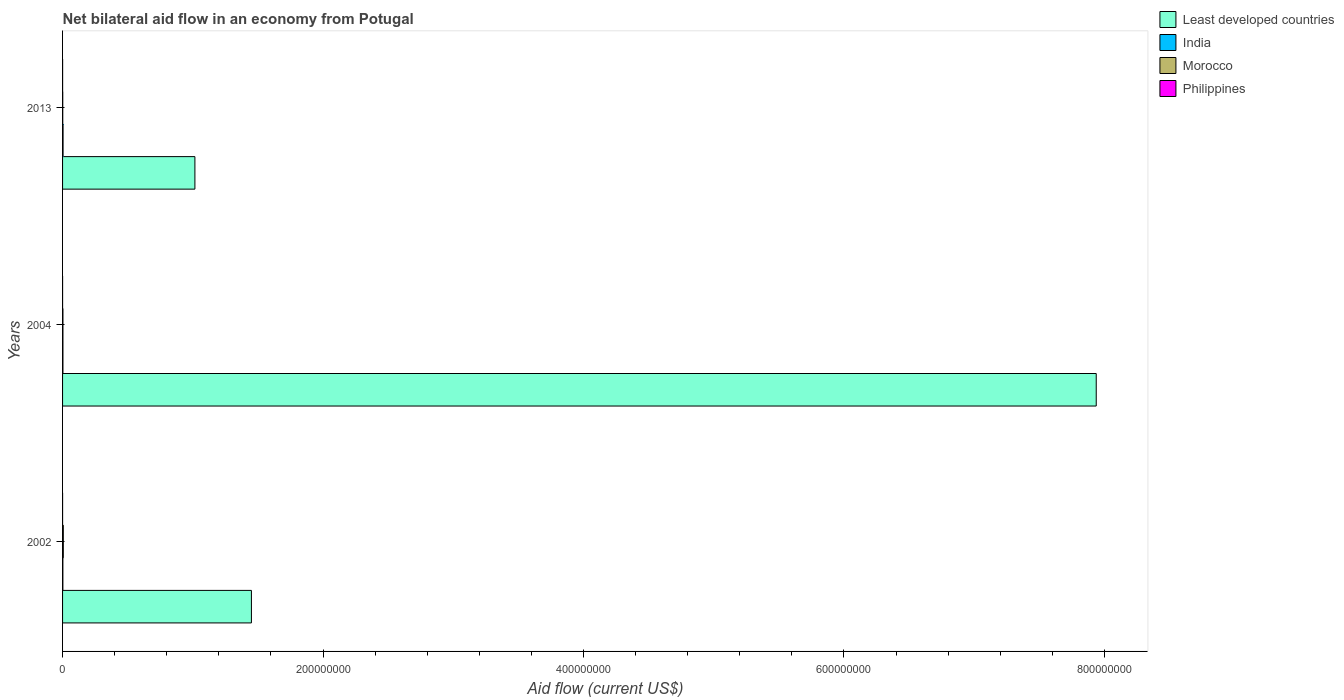How many different coloured bars are there?
Offer a terse response. 4. Are the number of bars per tick equal to the number of legend labels?
Make the answer very short. Yes. Are the number of bars on each tick of the Y-axis equal?
Provide a short and direct response. Yes. How many bars are there on the 3rd tick from the top?
Your answer should be compact. 4. Across all years, what is the maximum net bilateral aid flow in Morocco?
Your response must be concise. 5.70e+05. Across all years, what is the minimum net bilateral aid flow in Least developed countries?
Ensure brevity in your answer.  1.02e+08. In which year was the net bilateral aid flow in Morocco maximum?
Keep it short and to the point. 2002. What is the total net bilateral aid flow in Least developed countries in the graph?
Offer a very short reply. 1.04e+09. What is the difference between the net bilateral aid flow in Least developed countries in 2004 and that in 2013?
Provide a short and direct response. 6.92e+08. What is the difference between the net bilateral aid flow in India in 2004 and the net bilateral aid flow in Least developed countries in 2002?
Offer a very short reply. -1.45e+08. What is the average net bilateral aid flow in Morocco per year?
Your answer should be very brief. 3.33e+05. In the year 2002, what is the difference between the net bilateral aid flow in Least developed countries and net bilateral aid flow in Philippines?
Give a very brief answer. 1.45e+08. What is the ratio of the net bilateral aid flow in Least developed countries in 2002 to that in 2013?
Keep it short and to the point. 1.43. In how many years, is the net bilateral aid flow in Least developed countries greater than the average net bilateral aid flow in Least developed countries taken over all years?
Make the answer very short. 1. What does the 3rd bar from the top in 2004 represents?
Offer a very short reply. India. What does the 1st bar from the bottom in 2004 represents?
Ensure brevity in your answer.  Least developed countries. Is it the case that in every year, the sum of the net bilateral aid flow in India and net bilateral aid flow in Philippines is greater than the net bilateral aid flow in Least developed countries?
Provide a short and direct response. No. How many bars are there?
Offer a terse response. 12. Are all the bars in the graph horizontal?
Give a very brief answer. Yes. How many years are there in the graph?
Your response must be concise. 3. Does the graph contain any zero values?
Your answer should be compact. No. Does the graph contain grids?
Provide a short and direct response. No. What is the title of the graph?
Provide a succinct answer. Net bilateral aid flow in an economy from Potugal. What is the Aid flow (current US$) of Least developed countries in 2002?
Make the answer very short. 1.45e+08. What is the Aid flow (current US$) in Morocco in 2002?
Your answer should be compact. 5.70e+05. What is the Aid flow (current US$) of Least developed countries in 2004?
Your answer should be very brief. 7.94e+08. What is the Aid flow (current US$) in India in 2004?
Provide a short and direct response. 2.90e+05. What is the Aid flow (current US$) of Least developed countries in 2013?
Provide a succinct answer. 1.02e+08. What is the Aid flow (current US$) in Philippines in 2013?
Provide a short and direct response. 3.00e+04. Across all years, what is the maximum Aid flow (current US$) of Least developed countries?
Offer a terse response. 7.94e+08. Across all years, what is the maximum Aid flow (current US$) in India?
Offer a very short reply. 3.80e+05. Across all years, what is the maximum Aid flow (current US$) of Morocco?
Make the answer very short. 5.70e+05. Across all years, what is the minimum Aid flow (current US$) of Least developed countries?
Provide a short and direct response. 1.02e+08. Across all years, what is the minimum Aid flow (current US$) in Morocco?
Ensure brevity in your answer.  1.40e+05. What is the total Aid flow (current US$) of Least developed countries in the graph?
Make the answer very short. 1.04e+09. What is the total Aid flow (current US$) of India in the graph?
Give a very brief answer. 9.10e+05. What is the total Aid flow (current US$) of Morocco in the graph?
Keep it short and to the point. 1.00e+06. What is the total Aid flow (current US$) of Philippines in the graph?
Your answer should be compact. 5.00e+04. What is the difference between the Aid flow (current US$) in Least developed countries in 2002 and that in 2004?
Offer a very short reply. -6.49e+08. What is the difference between the Aid flow (current US$) of India in 2002 and that in 2004?
Provide a succinct answer. -5.00e+04. What is the difference between the Aid flow (current US$) of Philippines in 2002 and that in 2004?
Make the answer very short. 0. What is the difference between the Aid flow (current US$) of Least developed countries in 2002 and that in 2013?
Your response must be concise. 4.34e+07. What is the difference between the Aid flow (current US$) of Morocco in 2002 and that in 2013?
Your answer should be very brief. 4.30e+05. What is the difference between the Aid flow (current US$) of Least developed countries in 2004 and that in 2013?
Give a very brief answer. 6.92e+08. What is the difference between the Aid flow (current US$) in Philippines in 2004 and that in 2013?
Make the answer very short. -2.00e+04. What is the difference between the Aid flow (current US$) in Least developed countries in 2002 and the Aid flow (current US$) in India in 2004?
Your response must be concise. 1.45e+08. What is the difference between the Aid flow (current US$) of Least developed countries in 2002 and the Aid flow (current US$) of Morocco in 2004?
Your answer should be compact. 1.45e+08. What is the difference between the Aid flow (current US$) in Least developed countries in 2002 and the Aid flow (current US$) in Philippines in 2004?
Your answer should be very brief. 1.45e+08. What is the difference between the Aid flow (current US$) in Morocco in 2002 and the Aid flow (current US$) in Philippines in 2004?
Offer a very short reply. 5.60e+05. What is the difference between the Aid flow (current US$) of Least developed countries in 2002 and the Aid flow (current US$) of India in 2013?
Offer a very short reply. 1.45e+08. What is the difference between the Aid flow (current US$) in Least developed countries in 2002 and the Aid flow (current US$) in Morocco in 2013?
Provide a succinct answer. 1.45e+08. What is the difference between the Aid flow (current US$) of Least developed countries in 2002 and the Aid flow (current US$) of Philippines in 2013?
Your answer should be very brief. 1.45e+08. What is the difference between the Aid flow (current US$) of India in 2002 and the Aid flow (current US$) of Philippines in 2013?
Your answer should be very brief. 2.10e+05. What is the difference between the Aid flow (current US$) in Morocco in 2002 and the Aid flow (current US$) in Philippines in 2013?
Offer a very short reply. 5.40e+05. What is the difference between the Aid flow (current US$) in Least developed countries in 2004 and the Aid flow (current US$) in India in 2013?
Ensure brevity in your answer.  7.93e+08. What is the difference between the Aid flow (current US$) in Least developed countries in 2004 and the Aid flow (current US$) in Morocco in 2013?
Make the answer very short. 7.94e+08. What is the difference between the Aid flow (current US$) of Least developed countries in 2004 and the Aid flow (current US$) of Philippines in 2013?
Offer a very short reply. 7.94e+08. What is the difference between the Aid flow (current US$) of India in 2004 and the Aid flow (current US$) of Morocco in 2013?
Provide a short and direct response. 1.50e+05. What is the difference between the Aid flow (current US$) of India in 2004 and the Aid flow (current US$) of Philippines in 2013?
Make the answer very short. 2.60e+05. What is the average Aid flow (current US$) in Least developed countries per year?
Keep it short and to the point. 3.47e+08. What is the average Aid flow (current US$) of India per year?
Make the answer very short. 3.03e+05. What is the average Aid flow (current US$) in Morocco per year?
Ensure brevity in your answer.  3.33e+05. What is the average Aid flow (current US$) in Philippines per year?
Your response must be concise. 1.67e+04. In the year 2002, what is the difference between the Aid flow (current US$) in Least developed countries and Aid flow (current US$) in India?
Your answer should be compact. 1.45e+08. In the year 2002, what is the difference between the Aid flow (current US$) in Least developed countries and Aid flow (current US$) in Morocco?
Make the answer very short. 1.44e+08. In the year 2002, what is the difference between the Aid flow (current US$) in Least developed countries and Aid flow (current US$) in Philippines?
Ensure brevity in your answer.  1.45e+08. In the year 2002, what is the difference between the Aid flow (current US$) in India and Aid flow (current US$) in Morocco?
Make the answer very short. -3.30e+05. In the year 2002, what is the difference between the Aid flow (current US$) of Morocco and Aid flow (current US$) of Philippines?
Ensure brevity in your answer.  5.60e+05. In the year 2004, what is the difference between the Aid flow (current US$) of Least developed countries and Aid flow (current US$) of India?
Provide a short and direct response. 7.93e+08. In the year 2004, what is the difference between the Aid flow (current US$) of Least developed countries and Aid flow (current US$) of Morocco?
Your response must be concise. 7.93e+08. In the year 2004, what is the difference between the Aid flow (current US$) of Least developed countries and Aid flow (current US$) of Philippines?
Ensure brevity in your answer.  7.94e+08. In the year 2004, what is the difference between the Aid flow (current US$) in Morocco and Aid flow (current US$) in Philippines?
Keep it short and to the point. 2.80e+05. In the year 2013, what is the difference between the Aid flow (current US$) in Least developed countries and Aid flow (current US$) in India?
Your answer should be very brief. 1.01e+08. In the year 2013, what is the difference between the Aid flow (current US$) of Least developed countries and Aid flow (current US$) of Morocco?
Give a very brief answer. 1.01e+08. In the year 2013, what is the difference between the Aid flow (current US$) of Least developed countries and Aid flow (current US$) of Philippines?
Your answer should be compact. 1.02e+08. In the year 2013, what is the difference between the Aid flow (current US$) of India and Aid flow (current US$) of Morocco?
Offer a terse response. 2.40e+05. In the year 2013, what is the difference between the Aid flow (current US$) of Morocco and Aid flow (current US$) of Philippines?
Keep it short and to the point. 1.10e+05. What is the ratio of the Aid flow (current US$) of Least developed countries in 2002 to that in 2004?
Provide a short and direct response. 0.18. What is the ratio of the Aid flow (current US$) in India in 2002 to that in 2004?
Your answer should be compact. 0.83. What is the ratio of the Aid flow (current US$) of Morocco in 2002 to that in 2004?
Provide a short and direct response. 1.97. What is the ratio of the Aid flow (current US$) in Philippines in 2002 to that in 2004?
Provide a short and direct response. 1. What is the ratio of the Aid flow (current US$) in Least developed countries in 2002 to that in 2013?
Ensure brevity in your answer.  1.43. What is the ratio of the Aid flow (current US$) in India in 2002 to that in 2013?
Your response must be concise. 0.63. What is the ratio of the Aid flow (current US$) of Morocco in 2002 to that in 2013?
Give a very brief answer. 4.07. What is the ratio of the Aid flow (current US$) in Least developed countries in 2004 to that in 2013?
Your answer should be very brief. 7.81. What is the ratio of the Aid flow (current US$) of India in 2004 to that in 2013?
Make the answer very short. 0.76. What is the ratio of the Aid flow (current US$) in Morocco in 2004 to that in 2013?
Your answer should be very brief. 2.07. What is the difference between the highest and the second highest Aid flow (current US$) of Least developed countries?
Make the answer very short. 6.49e+08. What is the difference between the highest and the second highest Aid flow (current US$) of India?
Give a very brief answer. 9.00e+04. What is the difference between the highest and the second highest Aid flow (current US$) of Morocco?
Keep it short and to the point. 2.80e+05. What is the difference between the highest and the second highest Aid flow (current US$) in Philippines?
Offer a terse response. 2.00e+04. What is the difference between the highest and the lowest Aid flow (current US$) in Least developed countries?
Your answer should be compact. 6.92e+08. What is the difference between the highest and the lowest Aid flow (current US$) in India?
Your answer should be compact. 1.40e+05. What is the difference between the highest and the lowest Aid flow (current US$) in Morocco?
Offer a very short reply. 4.30e+05. What is the difference between the highest and the lowest Aid flow (current US$) of Philippines?
Keep it short and to the point. 2.00e+04. 